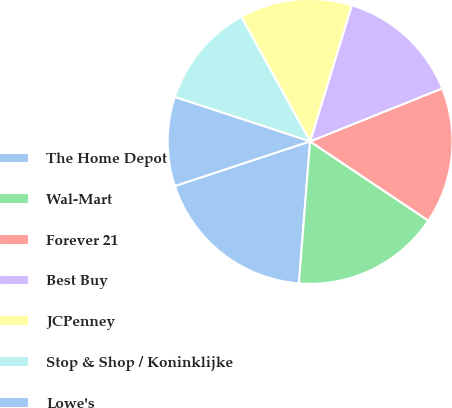Convert chart to OTSL. <chart><loc_0><loc_0><loc_500><loc_500><pie_chart><fcel>The Home Depot<fcel>Wal-Mart<fcel>Forever 21<fcel>Best Buy<fcel>JCPenney<fcel>Stop & Shop / Koninklijke<fcel>Lowe's<nl><fcel>18.68%<fcel>16.86%<fcel>15.46%<fcel>14.2%<fcel>12.77%<fcel>11.92%<fcel>10.12%<nl></chart> 